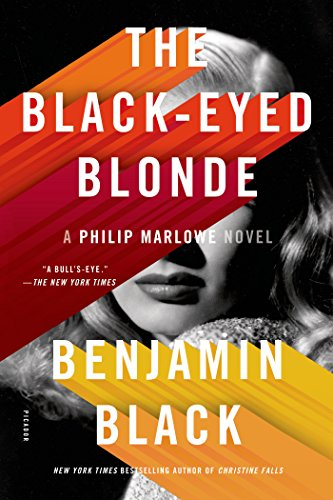Is this book related to Mystery, Thriller & Suspense? Yes, indeed, this book is a thrilling addition to the 'Mystery, Thriller & Suspense' genres, featuring a gripping storyline that involves detective work and suspenseful scenarios. 